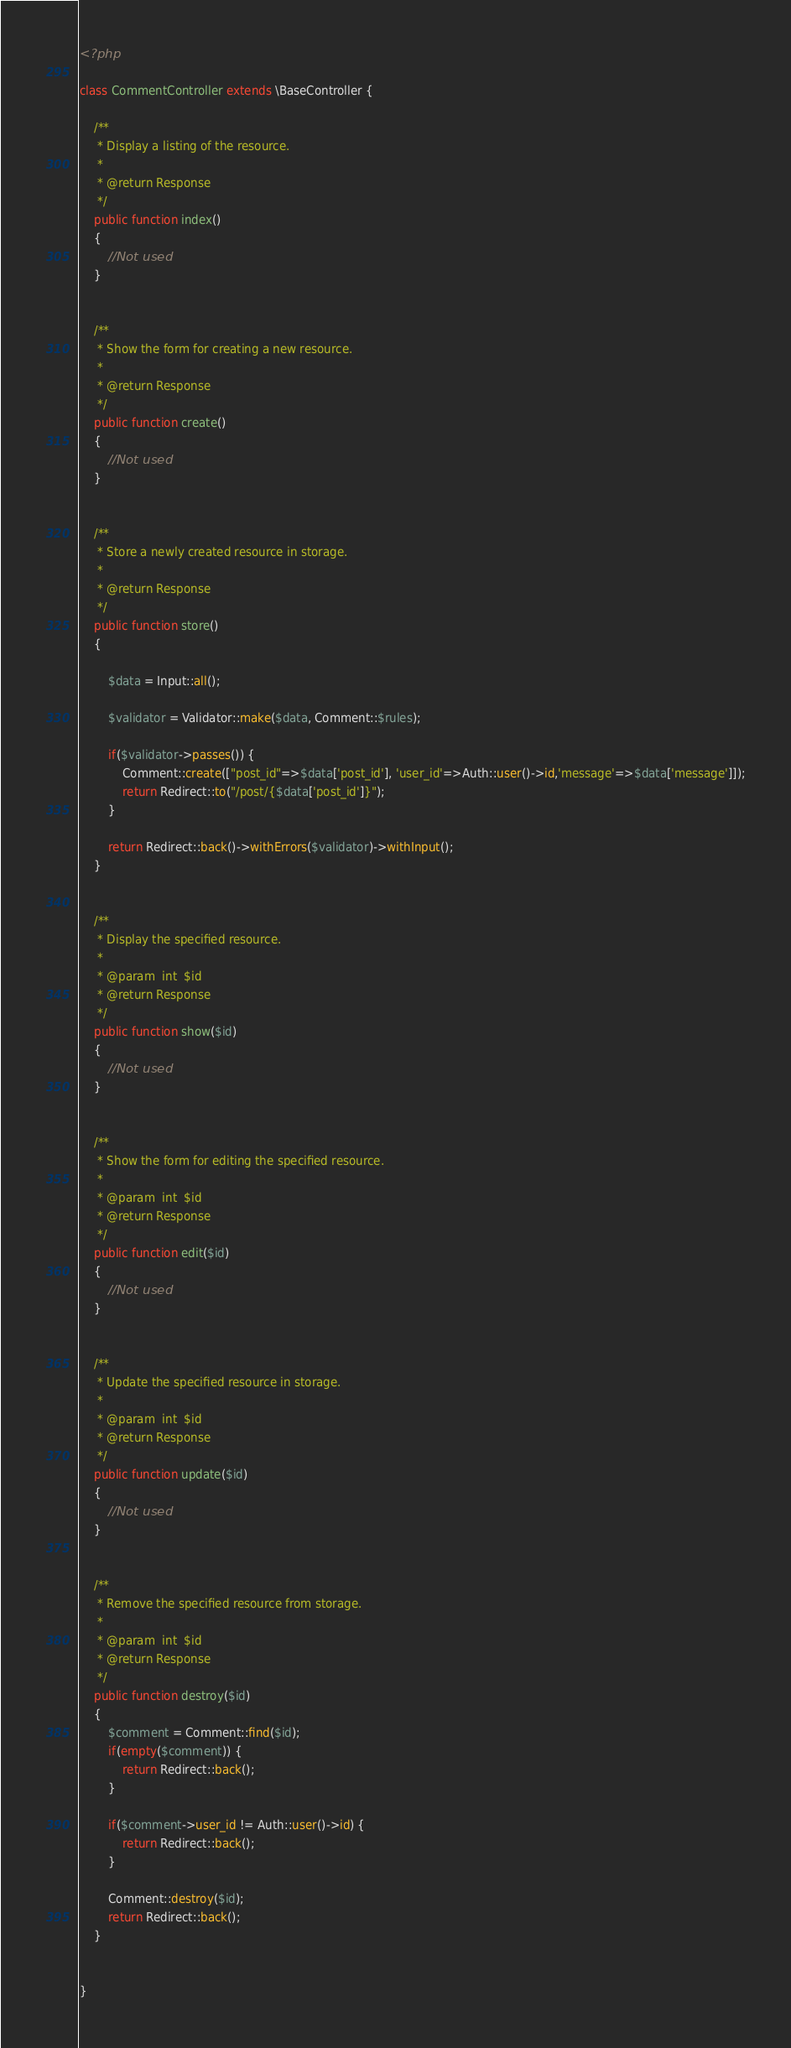Convert code to text. <code><loc_0><loc_0><loc_500><loc_500><_PHP_><?php

class CommentController extends \BaseController {

	/**
	 * Display a listing of the resource.
	 *
	 * @return Response
	 */
	public function index()
	{
		//Not used
	}


	/**
	 * Show the form for creating a new resource.
	 *
	 * @return Response
	 */
	public function create()
	{
		//Not used
	}


	/**
	 * Store a newly created resource in storage.
	 *
	 * @return Response
	 */
	public function store()
	{
	
		$data = Input::all();
		
		$validator = Validator::make($data, Comment::$rules);
		
		if($validator->passes()) {
			Comment::create(["post_id"=>$data['post_id'], 'user_id'=>Auth::user()->id,'message'=>$data['message']]);
			return Redirect::to("/post/{$data['post_id']}");
		}
		
		return Redirect::back()->withErrors($validator)->withInput();
	}


	/**
	 * Display the specified resource.
	 *
	 * @param  int  $id
	 * @return Response
	 */
	public function show($id)
	{
		//Not used
	}


	/**
	 * Show the form for editing the specified resource.
	 *
	 * @param  int  $id
	 * @return Response
	 */
	public function edit($id)
	{
		//Not used
	}


	/**
	 * Update the specified resource in storage.
	 *
	 * @param  int  $id
	 * @return Response
	 */
	public function update($id)
	{
		//Not used
	}


	/**
	 * Remove the specified resource from storage.
	 *
	 * @param  int  $id
	 * @return Response
	 */
	public function destroy($id)
	{
		$comment = Comment::find($id);
		if(empty($comment)) {
			return Redirect::back();
		}	
		
		if($comment->user_id != Auth::user()->id) {
			return Redirect::back();
		}
		
		Comment::destroy($id);
		return Redirect::back();
	}


}
</code> 